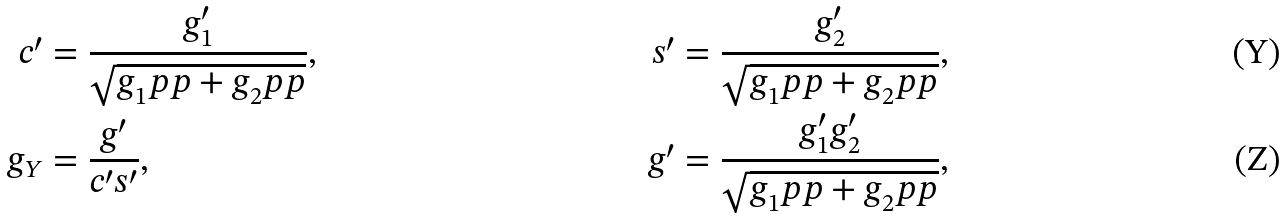Convert formula to latex. <formula><loc_0><loc_0><loc_500><loc_500>c ^ { \prime } & = \frac { g _ { 1 } ^ { \prime } } { \sqrt { g _ { 1 } ^ { \ } p p + g _ { 2 } ^ { \ } p p } } , & s ^ { \prime } & = \frac { g _ { 2 } ^ { \prime } } { \sqrt { g _ { 1 } ^ { \ } p p + g _ { 2 } ^ { \ } p p } } , \\ g _ { Y } & = \frac { g ^ { \prime } } { c ^ { \prime } s ^ { \prime } } , & g ^ { \prime } & = \frac { g _ { 1 } ^ { \prime } g _ { 2 } ^ { \prime } } { \sqrt { g _ { 1 } ^ { \ } p p + g _ { 2 } ^ { \ } p p } } ,</formula> 